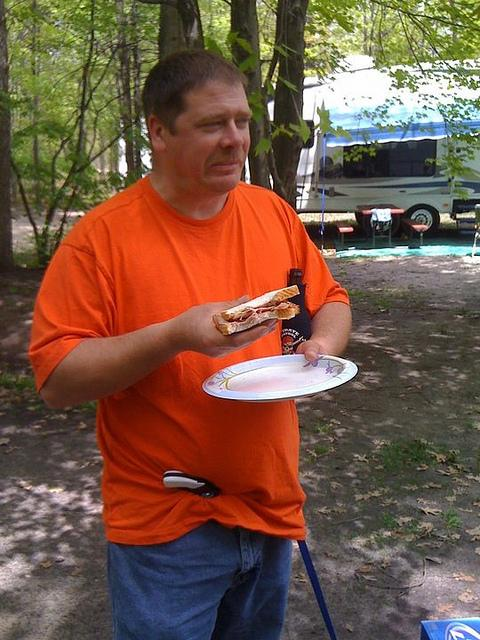How would this man defend himself if attacked? gun 